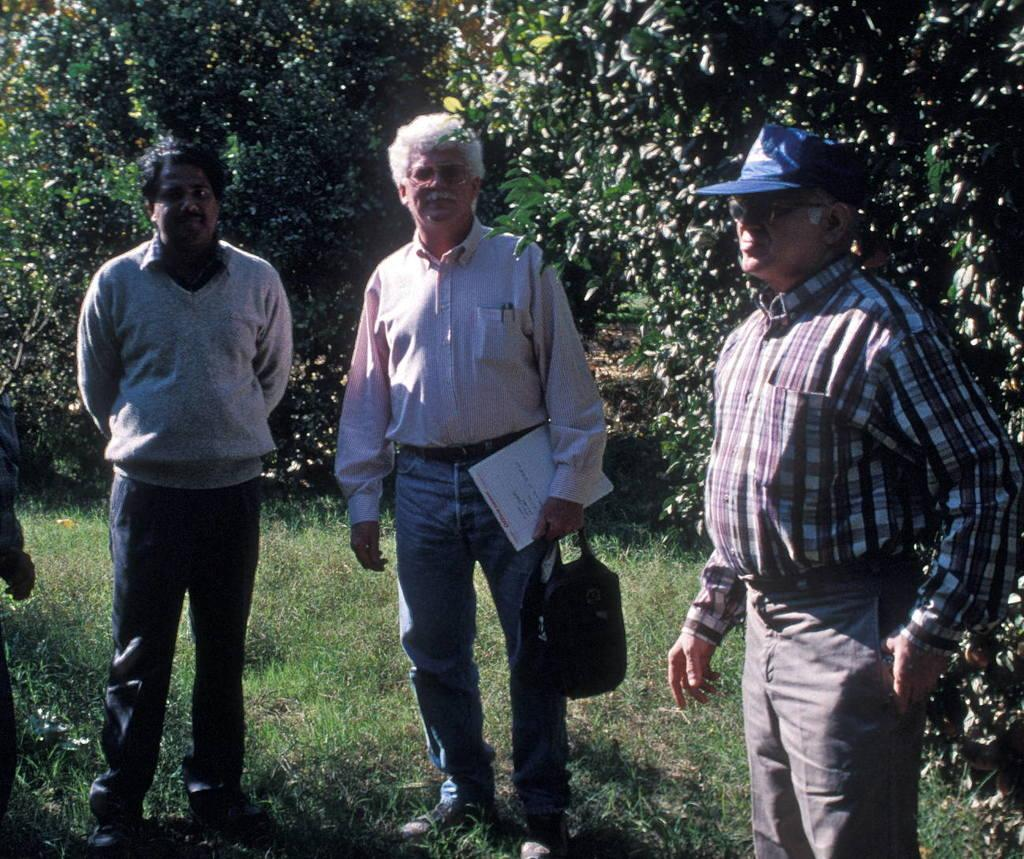How many people are in the image? There are three men in the image. What is the surface the men are standing on? The men are standing on the grass. What can be seen in the background of the image? There are trees visible in the background of the image. What type of doctor is standing in the middle of the image? There is no doctor present in the image; it features three men standing on the grass with trees visible in the background. 